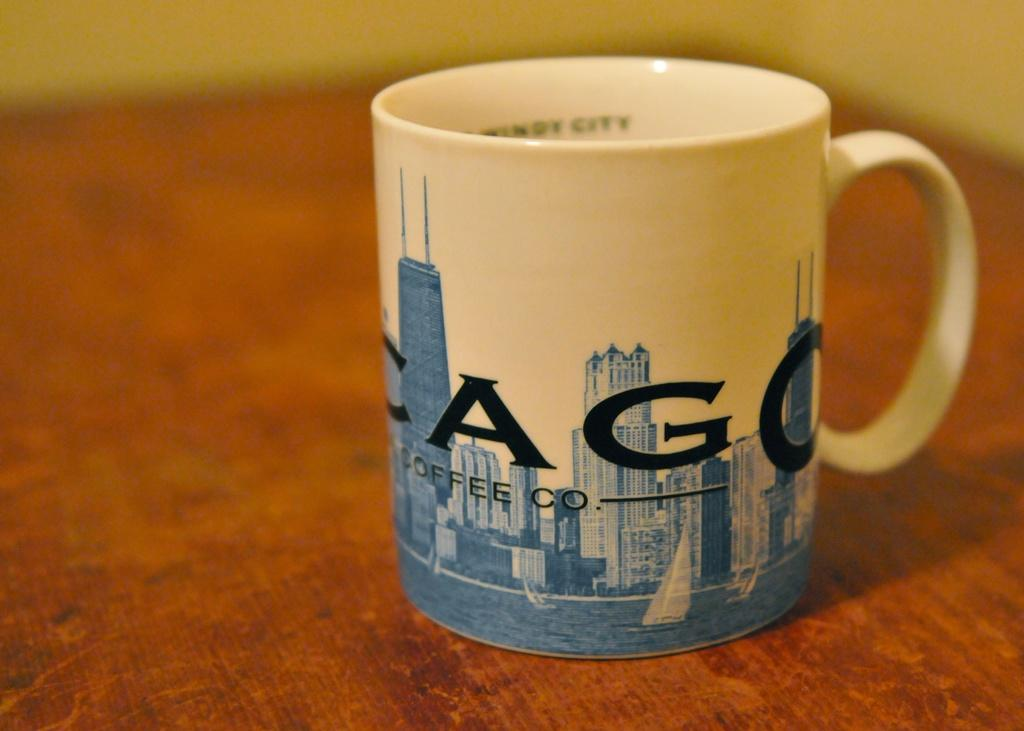<image>
Render a clear and concise summary of the photo. a mug with letters CAGO Coffee Co on a city skyline sits on a wood table 